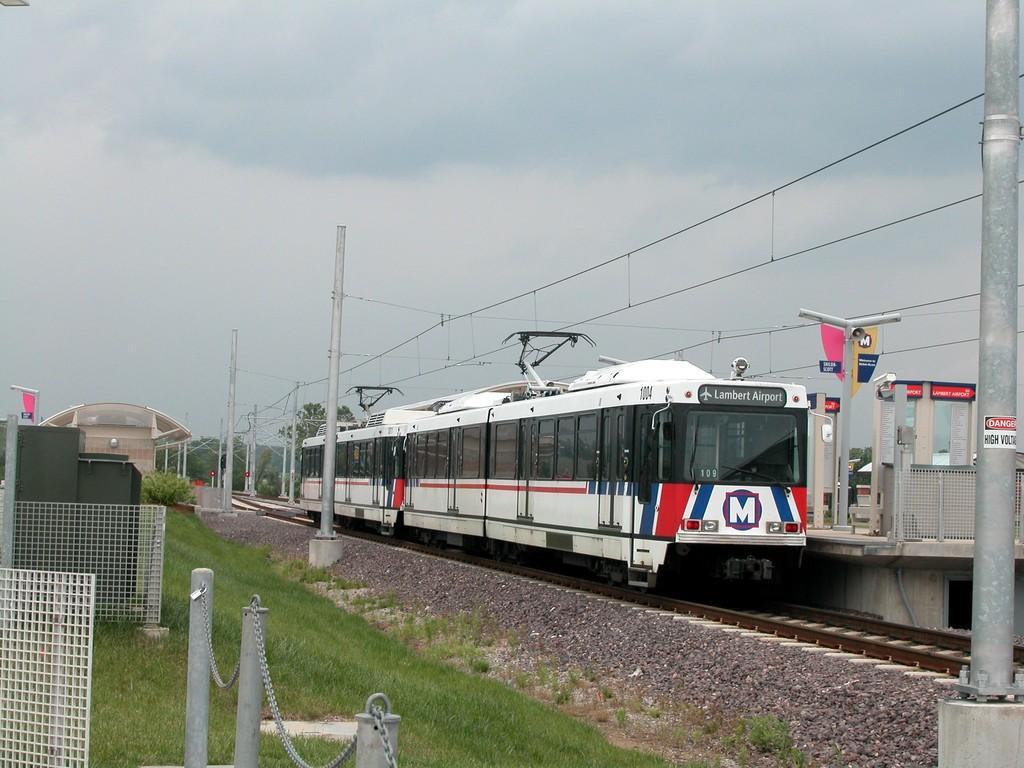Please provide a concise description of this image. In the image we can see the train on the train track. Here we can see electric poles and electric wires. Here we can see mesh, grass, stones and the cloudy sky. 